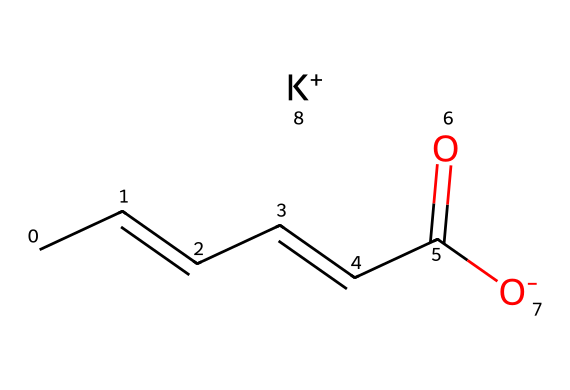What is the molecular formula of potassium sorbate? The molecular formula can be derived from the SMILES representation by identifying the elements and their quantities. In this case, we see five Carbon atoms, eight Hydrogen atoms, one Oxygen atom from the carbonyl group, and one oxygen from the carboxylate ion, along with a potassium ion. This leads to the formula C6H7KO2.
Answer: C6H7KO2 How many double bonds are present in potassium sorbate? By analyzing the SMILES representation, we can see that there are two double bonds indicated by "CC=CC=CC." This shows that there are two carbon-carbon double bonds.
Answer: 2 What type of functional group is present in potassium sorbate? The presence of the -COO- group (carboxylate) in its structure indicates the presence of a carboxylic acid derivative. This can be recognized in the SMILES as the arrangement CC(=O)[O-].
Answer: carboxylate How does the structure of potassium sorbate contribute to its preservative function? The double bonds in the structure can react with free radicals and other reactive species that lead to spoilage, while the carboxylate group contributes to its solubility and interaction with microbial membranes, enhancing its preservative properties.
Answer: double bonds and carboxylate group What is the total number of atoms in potassium sorbate? From the components of the molecular formula C6H7KO2, there are a total of six Carbon, seven Hydrogen, one Potassium, and two Oxygen atoms. Adding these gives a total of 16 atoms.
Answer: 16 